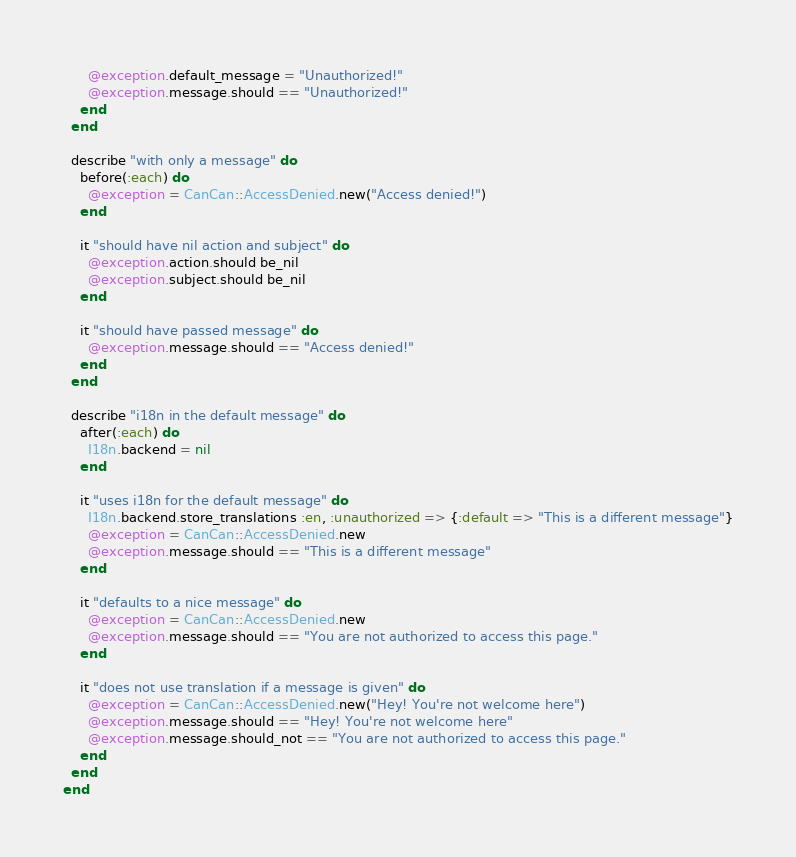Convert code to text. <code><loc_0><loc_0><loc_500><loc_500><_Ruby_>      @exception.default_message = "Unauthorized!"
      @exception.message.should == "Unauthorized!"
    end
  end

  describe "with only a message" do
    before(:each) do
      @exception = CanCan::AccessDenied.new("Access denied!")
    end

    it "should have nil action and subject" do
      @exception.action.should be_nil
      @exception.subject.should be_nil
    end

    it "should have passed message" do
      @exception.message.should == "Access denied!"
    end
  end
  
  describe "i18n in the default message" do
    after(:each) do
      I18n.backend = nil
    end
    
    it "uses i18n for the default message" do
      I18n.backend.store_translations :en, :unauthorized => {:default => "This is a different message"}
      @exception = CanCan::AccessDenied.new
      @exception.message.should == "This is a different message"
    end
    
    it "defaults to a nice message" do
      @exception = CanCan::AccessDenied.new
      @exception.message.should == "You are not authorized to access this page."
    end
    
    it "does not use translation if a message is given" do
      @exception = CanCan::AccessDenied.new("Hey! You're not welcome here")
      @exception.message.should == "Hey! You're not welcome here"
      @exception.message.should_not == "You are not authorized to access this page."
    end
  end
end
</code> 